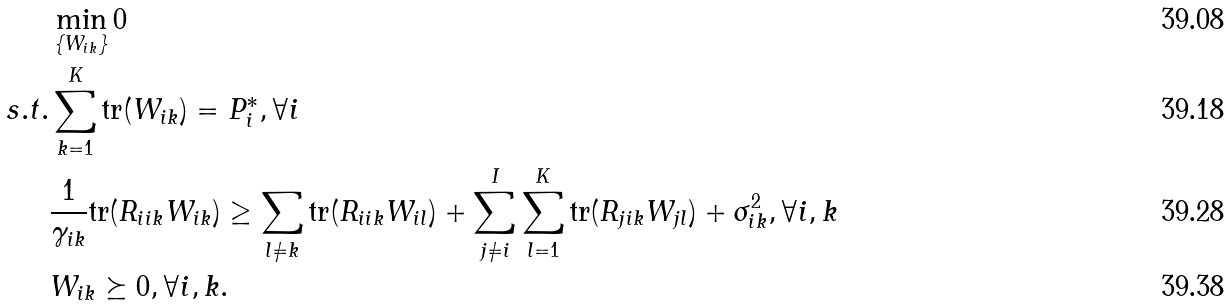Convert formula to latex. <formula><loc_0><loc_0><loc_500><loc_500>& \min _ { \{ W _ { i k } \} } 0 \\ s . t . & \sum _ { k = 1 } ^ { K } \text {tr} ( W _ { i k } ) = P _ { i } ^ { * } , \forall i \\ & \frac { 1 } { \gamma _ { i k } } \text {tr} ( R _ { i i k } W _ { i k } ) \geq \sum _ { l \neq k } \text {tr} ( R _ { i i k } W _ { i l } ) + \sum _ { j \neq i } ^ { I } \sum _ { l = 1 } ^ { K } \text {tr} ( R _ { j i k } W _ { j l } ) + \sigma _ { i k } ^ { 2 } , \forall i , k \\ & W _ { i k } \succeq 0 , \forall i , k .</formula> 